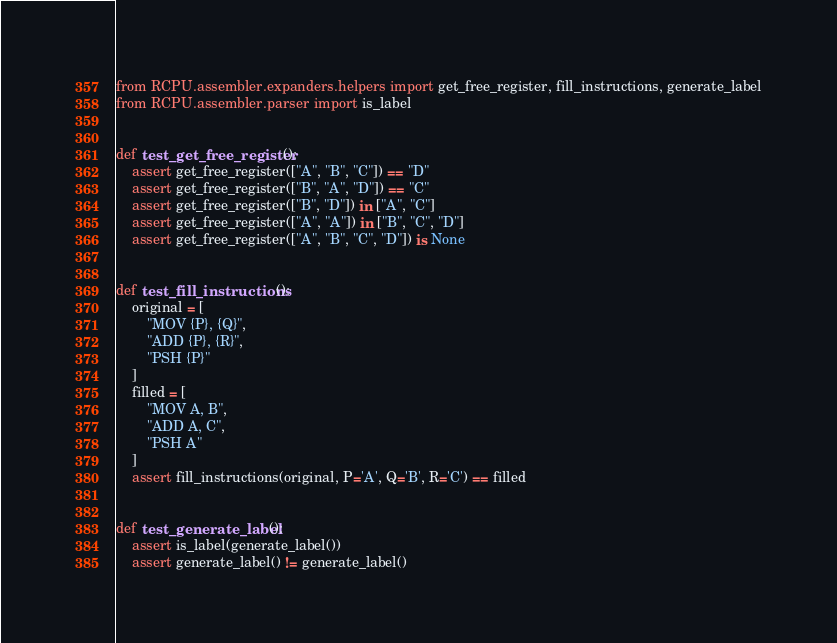Convert code to text. <code><loc_0><loc_0><loc_500><loc_500><_Python_>from RCPU.assembler.expanders.helpers import get_free_register, fill_instructions, generate_label
from RCPU.assembler.parser import is_label


def test_get_free_register():
    assert get_free_register(["A", "B", "C"]) == "D"
    assert get_free_register(["B", "A", "D"]) == "C"
    assert get_free_register(["B", "D"]) in ["A", "C"]
    assert get_free_register(["A", "A"]) in ["B", "C", "D"]
    assert get_free_register(["A", "B", "C", "D"]) is None


def test_fill_instructions():
    original = [
        "MOV {P}, {Q}",
        "ADD {P}, {R}",
        "PSH {P}"
    ]
    filled = [
        "MOV A, B",
        "ADD A, C",
        "PSH A"
    ]
    assert fill_instructions(original, P='A', Q='B', R='C') == filled


def test_generate_label():
    assert is_label(generate_label())
    assert generate_label() != generate_label()
</code> 